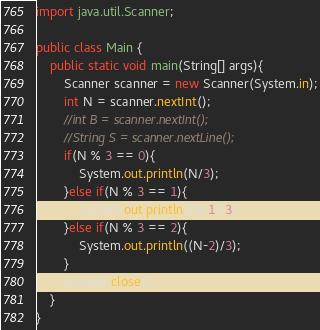<code> <loc_0><loc_0><loc_500><loc_500><_Java_>import java.util.Scanner;

public class Main {
	public static void main(String[] args){
		Scanner scanner = new Scanner(System.in);
		int N = scanner.nextInt();
		//int B = scanner.nextInt();
		//String S = scanner.nextLine();
		if(N % 3 == 0){
			System.out.println(N/3);
		}else if(N % 3 == 1){
			System.out.println((N-1)/3);
		}else if(N % 3 == 2){
			System.out.println((N-2)/3);
		}
		scanner.close();
	}
}
</code> 